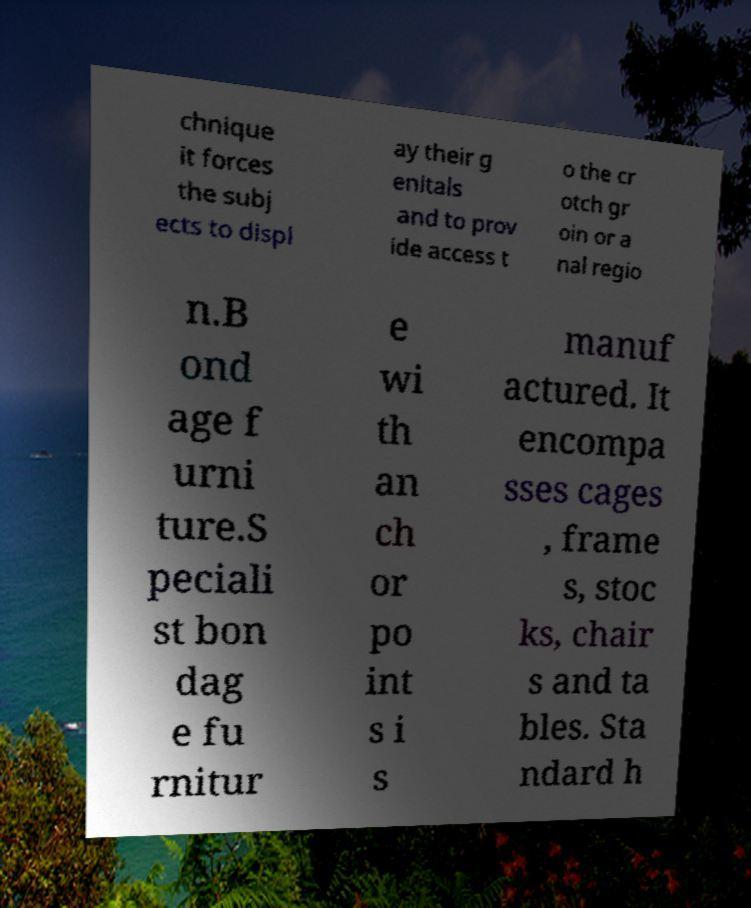Please read and relay the text visible in this image. What does it say? chnique it forces the subj ects to displ ay their g enitals and to prov ide access t o the cr otch gr oin or a nal regio n.B ond age f urni ture.S peciali st bon dag e fu rnitur e wi th an ch or po int s i s manuf actured. It encompa sses cages , frame s, stoc ks, chair s and ta bles. Sta ndard h 